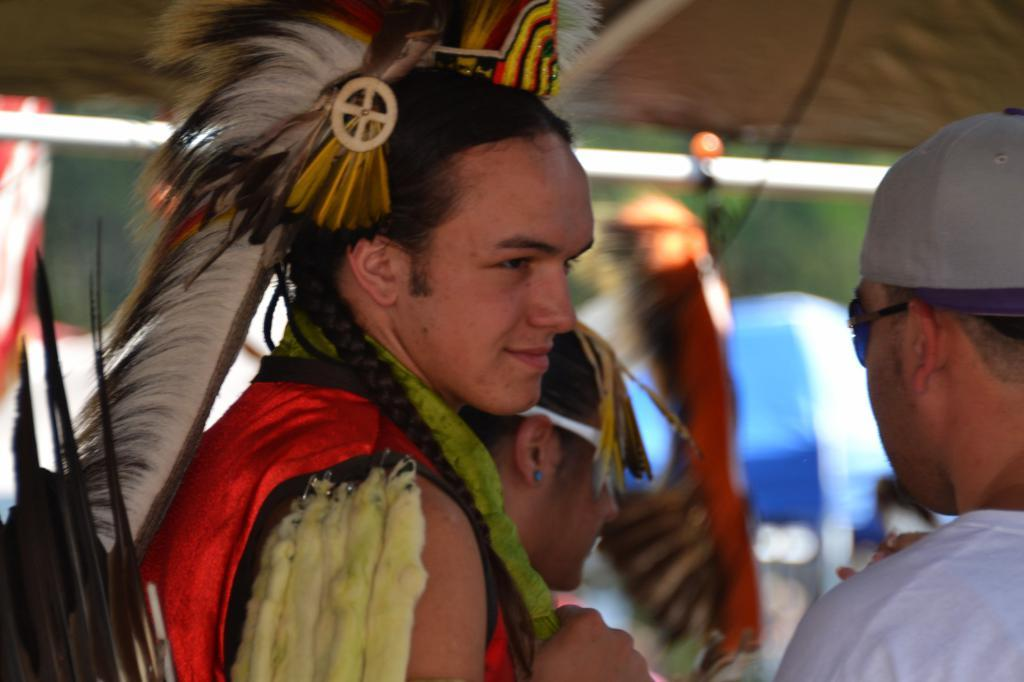What can be seen in the foreground of the image? There are people and objects in the front of the image. How would you describe the background of the image? The background of the image is blurry. How many teeth can be seen in the image? There are no teeth visible in the image. Are there any giants present in the image? There are no giants present in the image. 